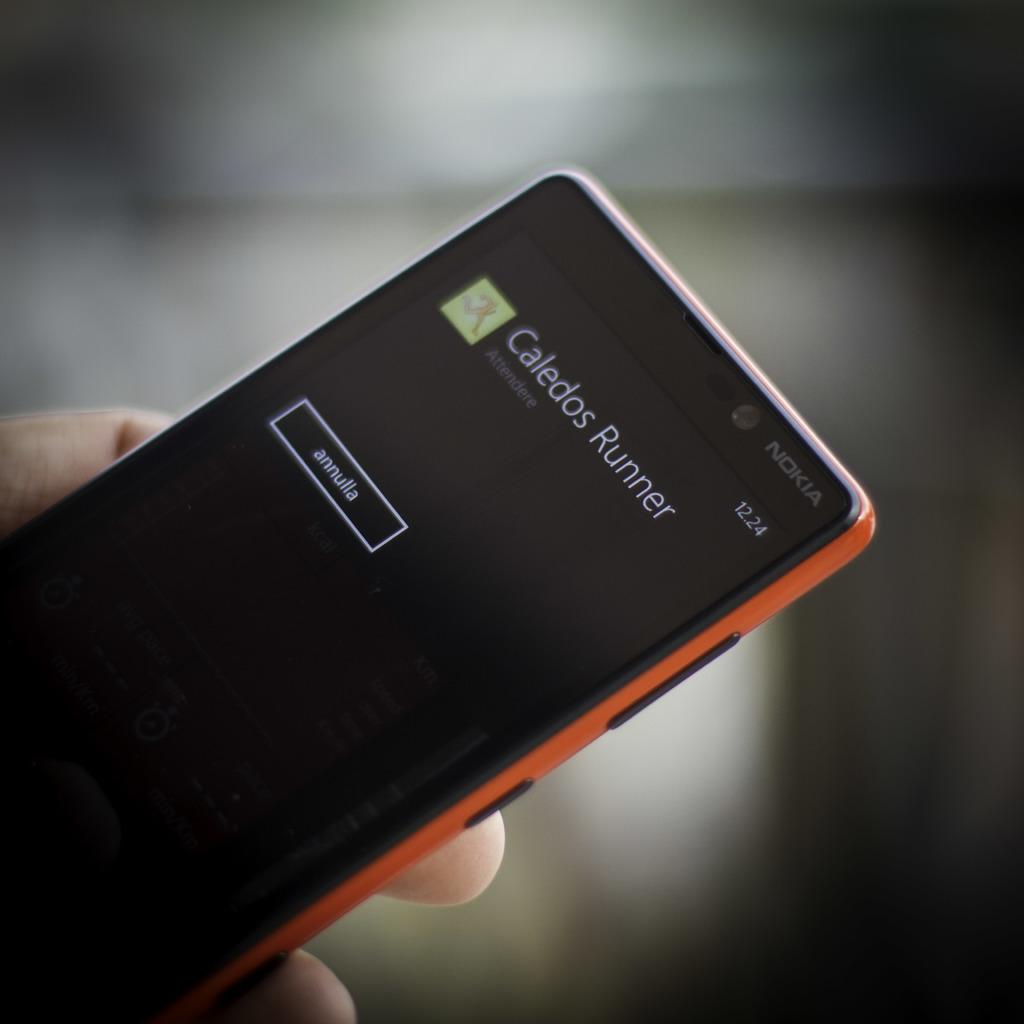<image>
Share a concise interpretation of the image provided. a phone with the name Caledos runner on it 